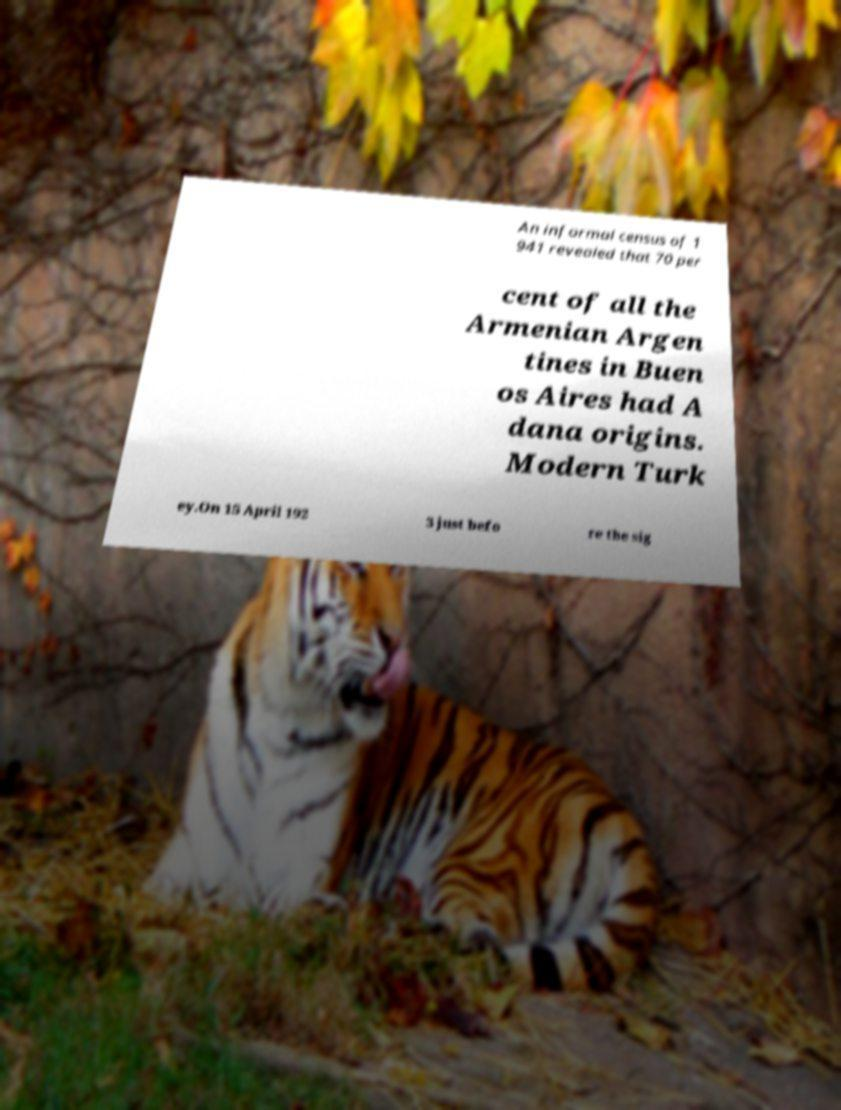Please read and relay the text visible in this image. What does it say? An informal census of 1 941 revealed that 70 per cent of all the Armenian Argen tines in Buen os Aires had A dana origins. Modern Turk ey.On 15 April 192 3 just befo re the sig 